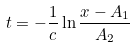<formula> <loc_0><loc_0><loc_500><loc_500>t = - \frac { 1 } { c } \ln \frac { x - A _ { 1 } } { A _ { 2 } }</formula> 